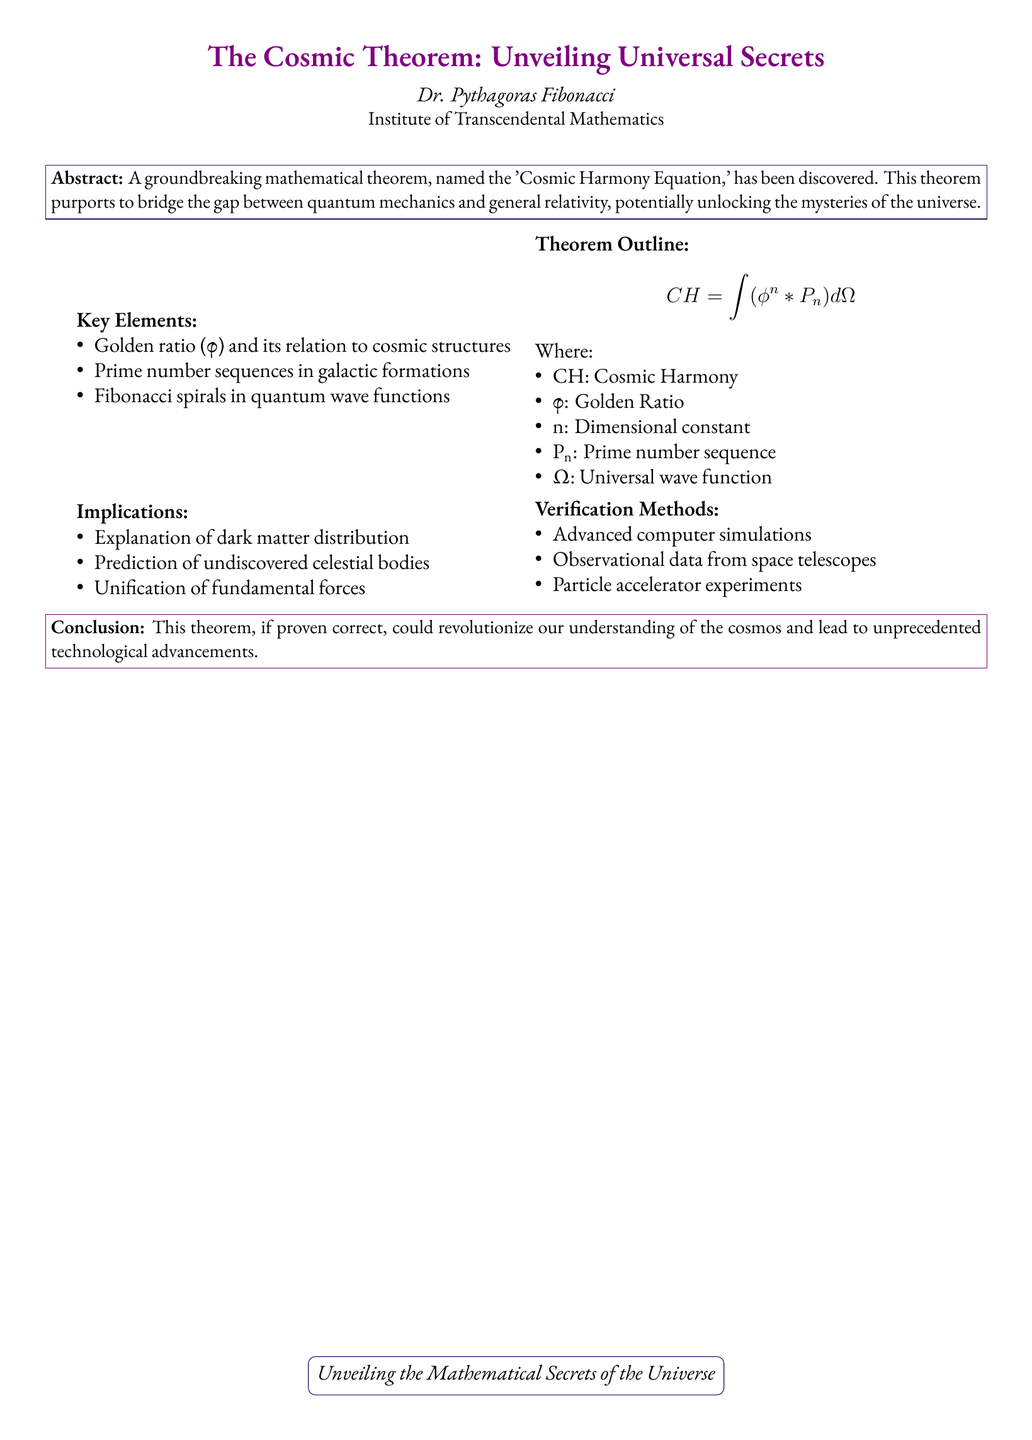What is the title of the manuscript? The title of the manuscript is prominently displayed at the top of the document.
Answer: The Cosmic Theorem: Unveiling Universal Secrets Who is the author of the manuscript? The author of the manuscript is mentioned directly under the title.
Answer: Dr. Pythagoras Fibonacci What mathematical equation is central to the theorem? The central equation of the theorem is highlighted in the outline section.
Answer: CH = ∫(φ^n * P_n) dΩ What aspect of the universe does the theorem aim to explain? The implications section mentions specific concepts related to cosmic mysteries.
Answer: Dark matter distribution What is one of the verification methods mentioned in the document? The verification methods section lists several techniques.
Answer: Advanced computer simulations What is the significance of the golden ratio in this manuscript? The key elements mention the relation of the golden ratio to cosmic structures.
Answer: Relation to cosmic structures How could this theorem affect our understanding of fundamental forces? The implications section suggests significant outcomes.
Answer: Unification of fundamental forces 